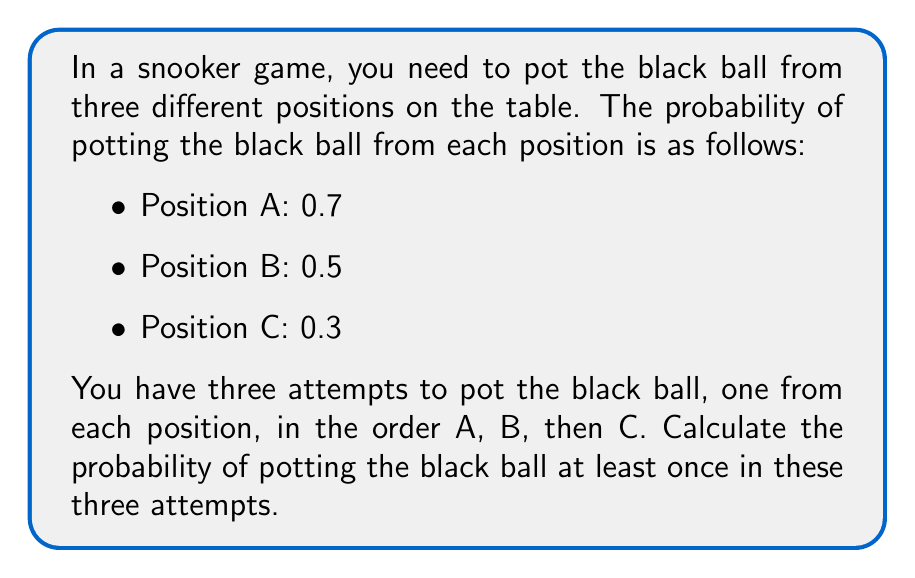Show me your answer to this math problem. To solve this problem, we'll use the concept of complementary events. Instead of calculating the probability of potting the ball at least once, we'll calculate the probability of not potting the ball in any of the three attempts and then subtract that from 1.

Step 1: Calculate the probability of not potting the ball from each position.
- Position A: $P(\text{not potting from A}) = 1 - 0.7 = 0.3$
- Position B: $P(\text{not potting from B}) = 1 - 0.5 = 0.5$
- Position C: $P(\text{not potting from C}) = 1 - 0.3 = 0.7$

Step 2: Calculate the probability of not potting the ball in any of the three attempts.
$P(\text{not potting in any attempt}) = 0.3 \times 0.5 \times 0.7 = 0.105$

Step 3: Calculate the probability of potting the ball at least once by subtracting the probability of not potting from 1.
$P(\text{potting at least once}) = 1 - P(\text{not potting in any attempt})$
$P(\text{potting at least once}) = 1 - 0.105 = 0.895$

Therefore, the probability of potting the black ball at least once in the three attempts is 0.895 or 89.5%.
Answer: 0.895 